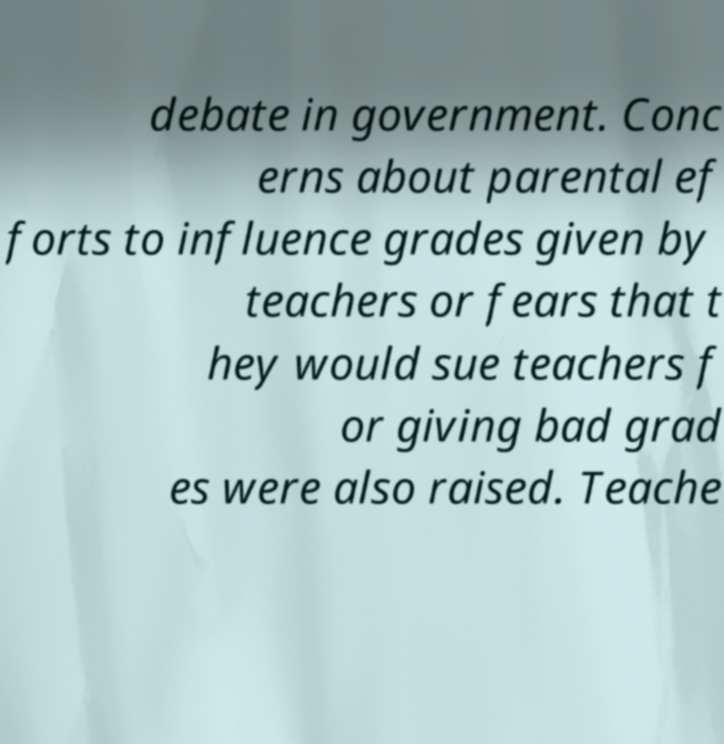Could you assist in decoding the text presented in this image and type it out clearly? debate in government. Conc erns about parental ef forts to influence grades given by teachers or fears that t hey would sue teachers f or giving bad grad es were also raised. Teache 